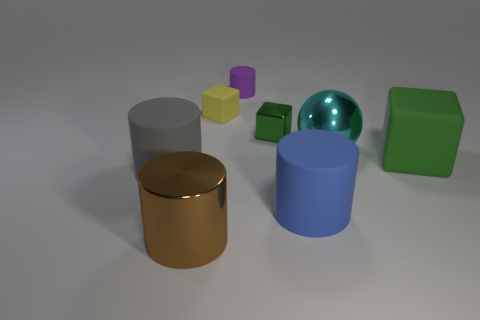There is a big rubber cylinder that is on the right side of the big cylinder that is behind the big cylinder that is on the right side of the shiny cube; what is its color?
Provide a short and direct response. Blue. What number of other things are the same shape as the tiny purple rubber thing?
Give a very brief answer. 3. What shape is the rubber object on the right side of the large ball?
Keep it short and to the point. Cube. There is a matte cylinder that is behind the gray cylinder; are there any big cyan shiny things in front of it?
Provide a short and direct response. Yes. What color is the shiny object that is both on the right side of the large brown object and on the left side of the big cyan metal thing?
Ensure brevity in your answer.  Green. There is a large rubber cylinder right of the large metal object that is to the left of the large metallic ball; is there a metal thing in front of it?
Your answer should be very brief. Yes. There is a purple object that is the same shape as the gray rubber object; what size is it?
Your response must be concise. Small. Is there a small yellow shiny cube?
Provide a short and direct response. No. Do the large rubber block and the metallic cube behind the blue cylinder have the same color?
Keep it short and to the point. Yes. What size is the matte block that is left of the rubber thing in front of the large rubber cylinder to the left of the brown cylinder?
Offer a terse response. Small. 